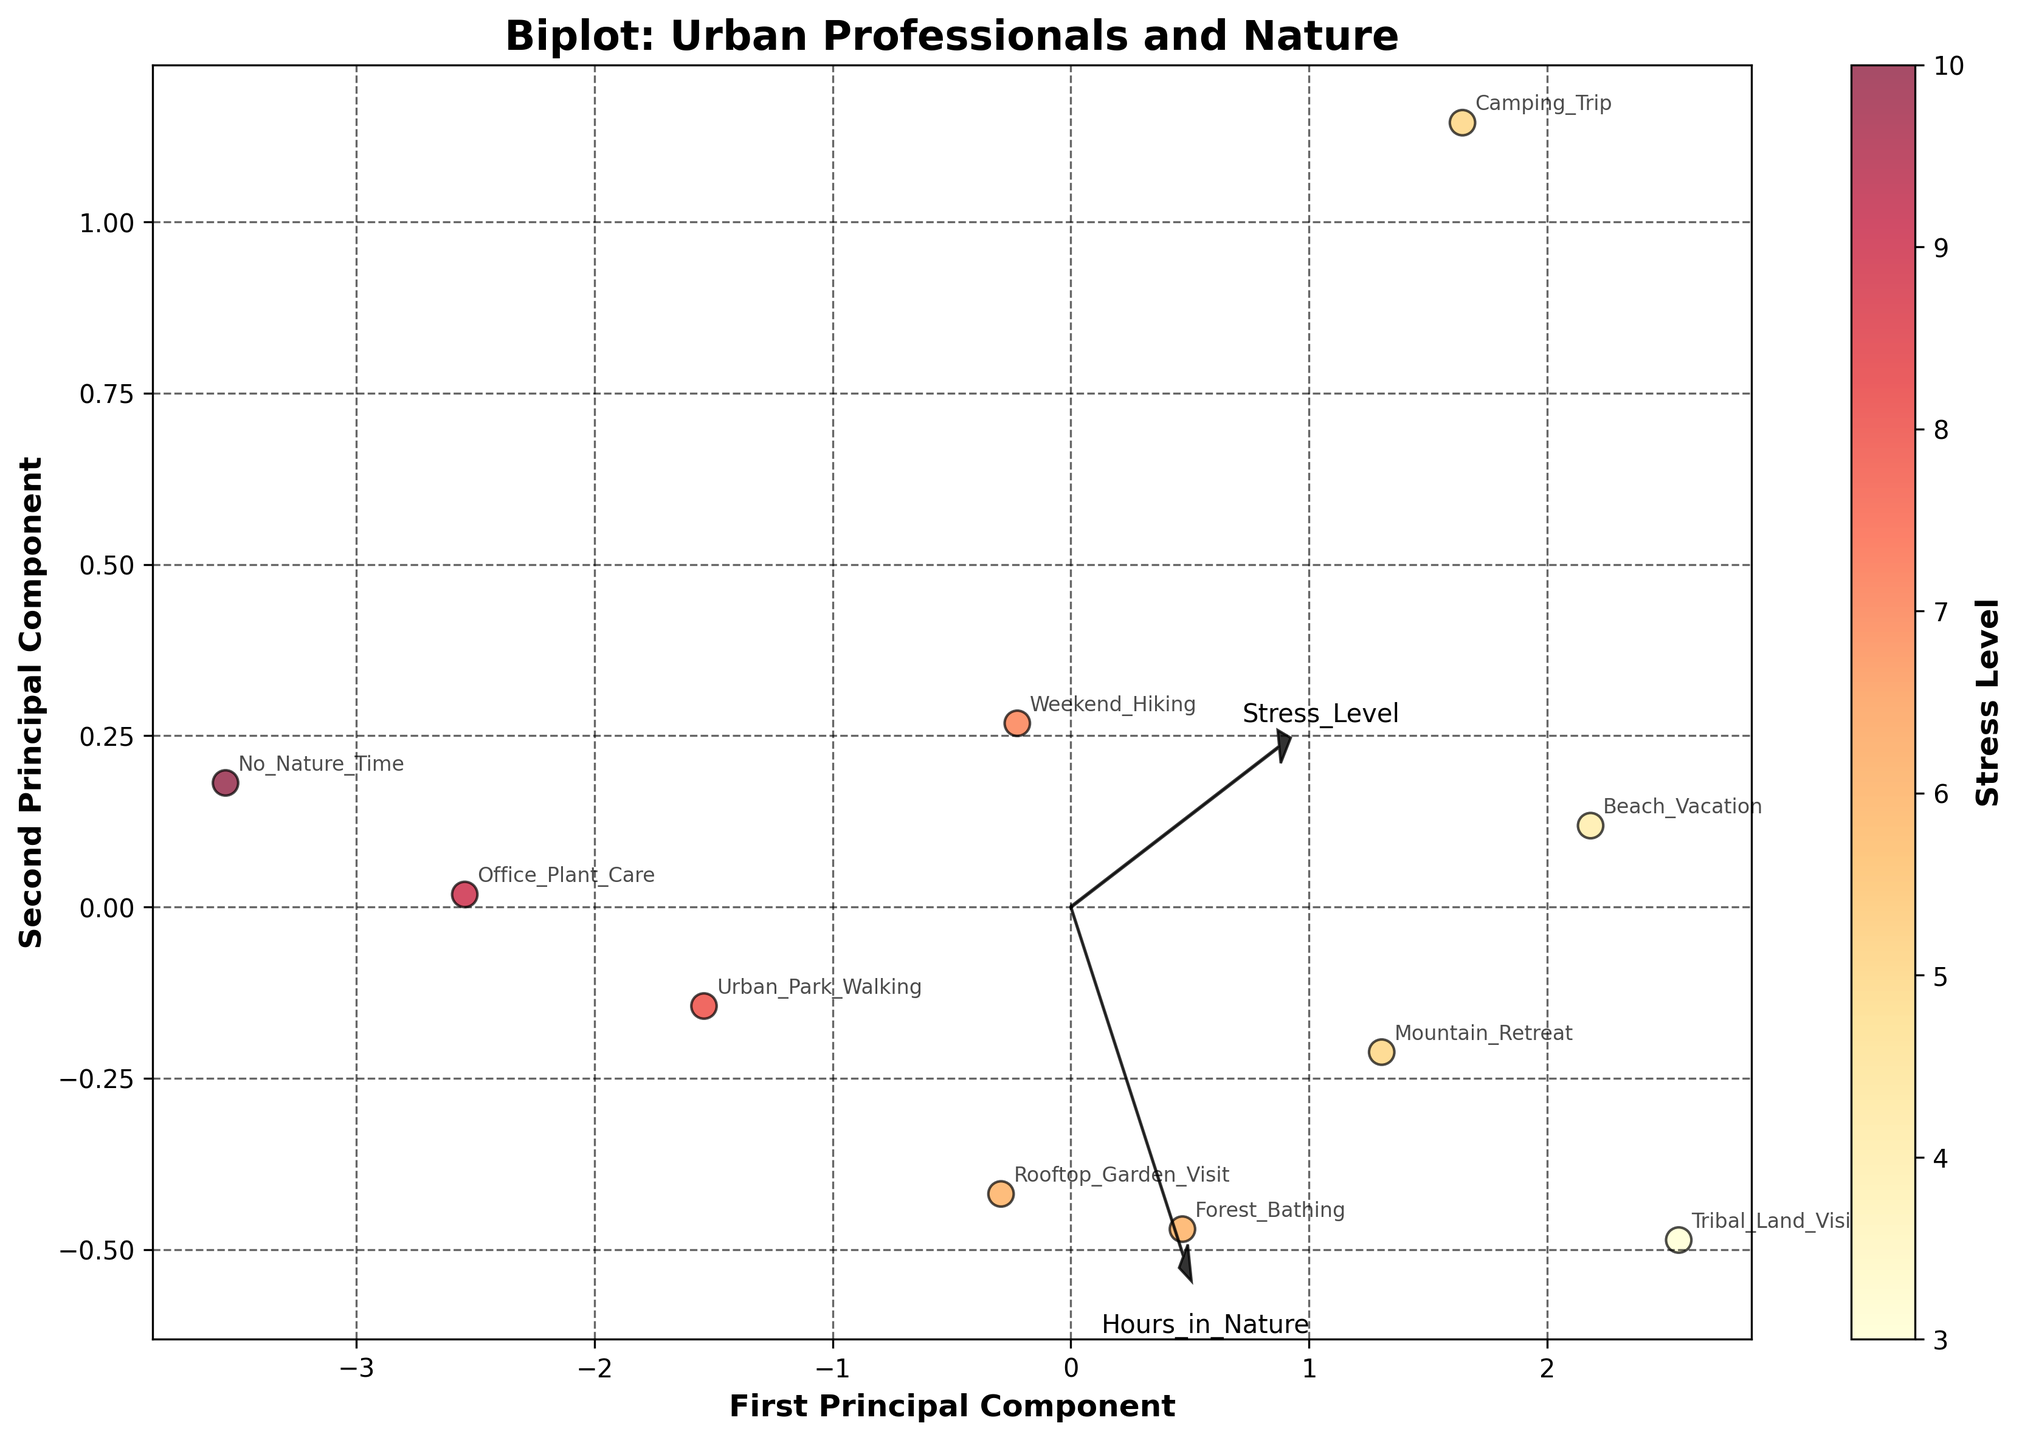What is the title of the Biplot? The title is often placed at the top of the plot. It is written in a clear font, indicating the main topic of the plot. In this Biplot, the title is observed directly.
Answer: Biplot: Urban Professionals and Nature How many principal components are shown in the Biplot? The Biplot typically displays two principal components to represent the data. These components are visible as axes labeled accordingly.
Answer: 2 Which Nature Activity has the lowest stress level? On the Biplot, stress level is indicated by color, with lower levels shown in lighter shades. Identify the Nature Activity nearest to the lightest points in the plot.
Answer: Tribal_Land_Visit What is the relationship between 'Hours in Nature' and 'Stress Level' based on the feature vectors? The arrows (feature vectors) in the Biplot show the direction and strength of the relationship between variables. Examine the orientation of the 'Hours in Nature' and 'Stress Level' arrows to each other.
Answer: Inversely related Which variable is most strongly associated with the second principal component? Feature vectors (arrows) with larger projections on the second principal component axis indicate a stronger association. Look for the variable with the longest arrow along this direction.
Answer: Work_Life_Balance How does 'Camping Trip' compare to 'No Nature Time' in terms of stress levels? Locate both activities on the Biplot, then compare their positions to the stress level gradient (color coded).
Answer: Camping Trip has a lower stress level compared to No Nature Time What does a longer arrow signify for a feature vector in a Biplot? In a Biplot, longer arrows for feature vectors indicate stronger influence in that direction, reflecting stronger association with the principal components. Compare the length of arrows for interpretation.
Answer: Stronger association Which activity shows the highest balance between Job Satisfaction and Work-Life Balance? Identify activities close to the 'Job Satisfaction' and 'Work-Life Balance' feature vectors in the Biplot. The one nearest to the positive ends of both vectors reflects high balance.
Answer: Tribal_Land_Visit 